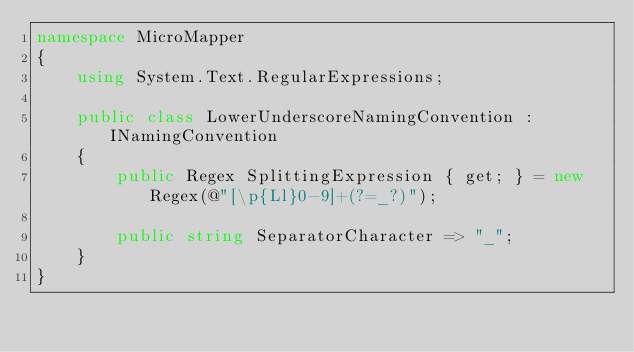<code> <loc_0><loc_0><loc_500><loc_500><_C#_>namespace MicroMapper
{
    using System.Text.RegularExpressions;

    public class LowerUnderscoreNamingConvention : INamingConvention
    {
        public Regex SplittingExpression { get; } = new Regex(@"[\p{Ll}0-9]+(?=_?)");

        public string SeparatorCharacter => "_";
    }
}</code> 